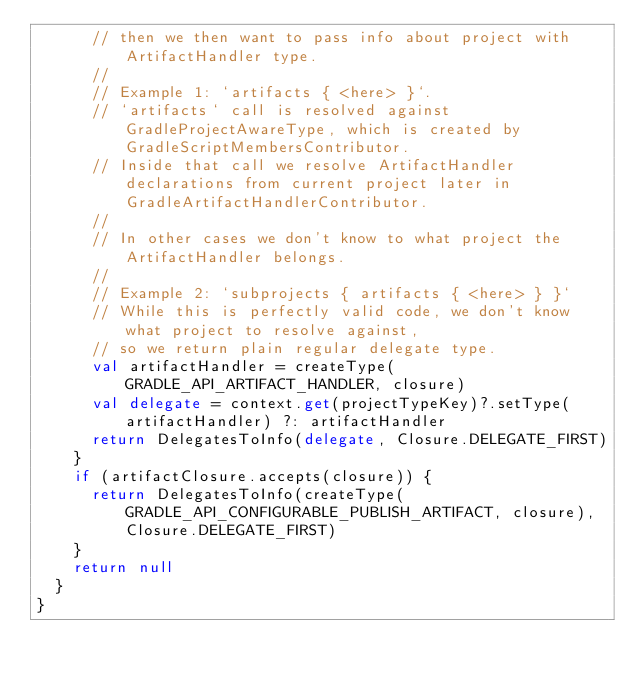<code> <loc_0><loc_0><loc_500><loc_500><_Kotlin_>      // then we then want to pass info about project with ArtifactHandler type.
      //
      // Example 1: `artifacts { <here> }`.
      // `artifacts` call is resolved against GradleProjectAwareType, which is created by GradleScriptMembersContributor.
      // Inside that call we resolve ArtifactHandler declarations from current project later in GradleArtifactHandlerContributor.
      //
      // In other cases we don't know to what project the ArtifactHandler belongs.
      //
      // Example 2: `subprojects { artifacts { <here> } }`
      // While this is perfectly valid code, we don't know what project to resolve against,
      // so we return plain regular delegate type.
      val artifactHandler = createType(GRADLE_API_ARTIFACT_HANDLER, closure)
      val delegate = context.get(projectTypeKey)?.setType(artifactHandler) ?: artifactHandler
      return DelegatesToInfo(delegate, Closure.DELEGATE_FIRST)
    }
    if (artifactClosure.accepts(closure)) {
      return DelegatesToInfo(createType(GRADLE_API_CONFIGURABLE_PUBLISH_ARTIFACT, closure), Closure.DELEGATE_FIRST)
    }
    return null
  }
}
</code> 